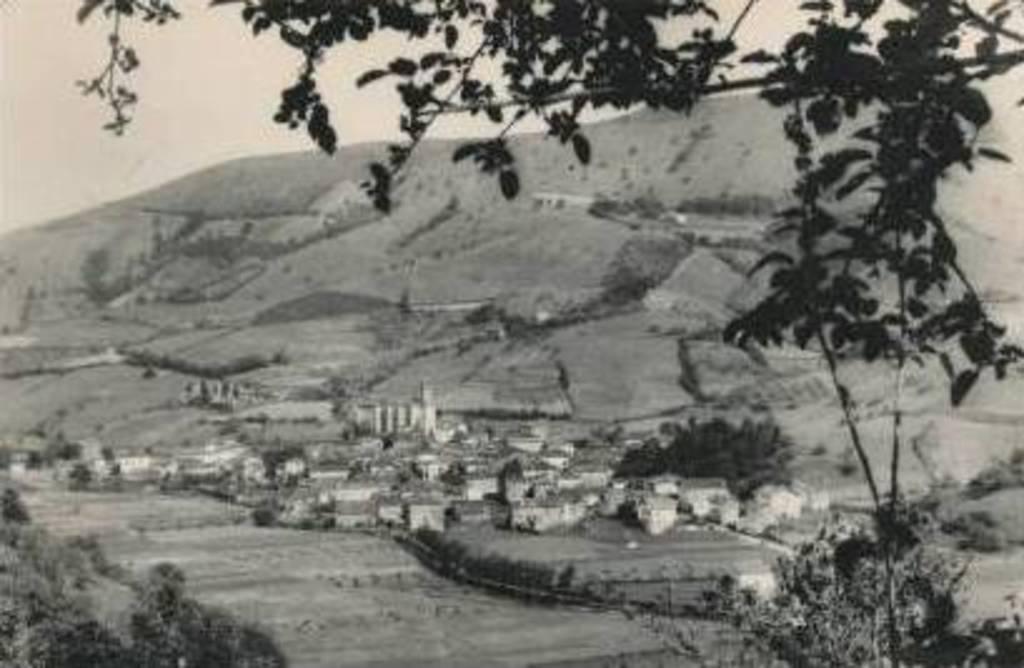Could you give a brief overview of what you see in this image? This image is slightly blurred which is in black and white where we can see trees, farmlands, houses, hills and the sky in the background. 